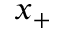<formula> <loc_0><loc_0><loc_500><loc_500>x _ { + }</formula> 